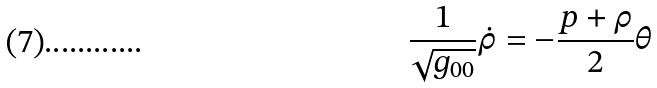Convert formula to latex. <formula><loc_0><loc_0><loc_500><loc_500>\frac { 1 } { \sqrt { g _ { 0 0 } } } \dot { \rho } = - \frac { p + \rho } { 2 } \theta</formula> 